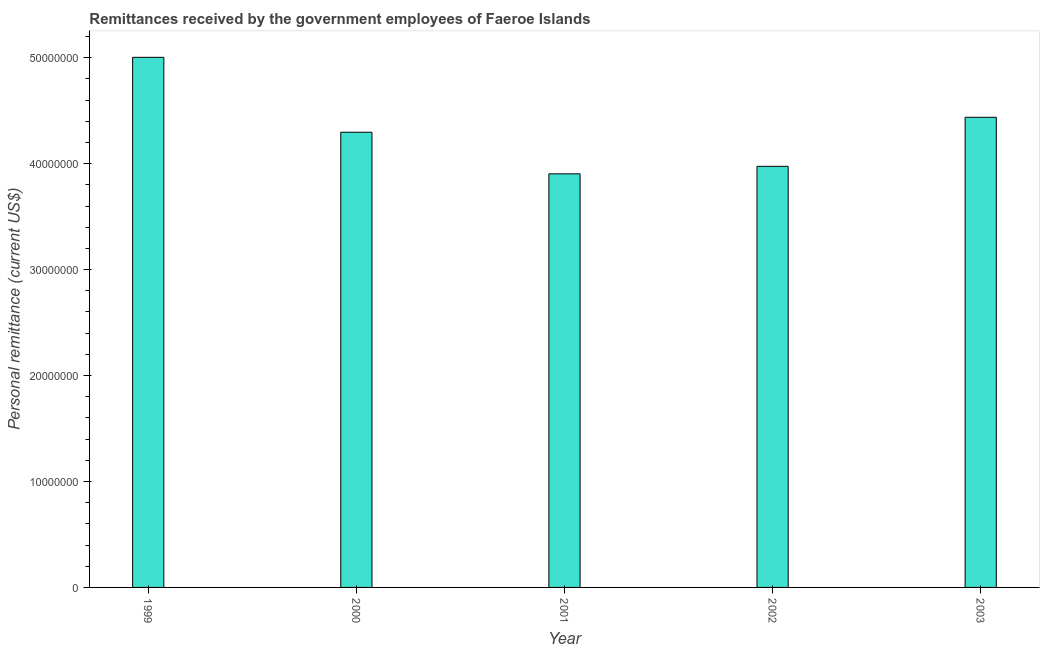Does the graph contain any zero values?
Your answer should be compact. No. Does the graph contain grids?
Provide a succinct answer. No. What is the title of the graph?
Give a very brief answer. Remittances received by the government employees of Faeroe Islands. What is the label or title of the X-axis?
Keep it short and to the point. Year. What is the label or title of the Y-axis?
Give a very brief answer. Personal remittance (current US$). What is the personal remittances in 2003?
Provide a succinct answer. 4.44e+07. Across all years, what is the maximum personal remittances?
Offer a very short reply. 5.00e+07. Across all years, what is the minimum personal remittances?
Your answer should be very brief. 3.90e+07. What is the sum of the personal remittances?
Offer a terse response. 2.16e+08. What is the difference between the personal remittances in 2000 and 2002?
Provide a short and direct response. 3.22e+06. What is the average personal remittances per year?
Give a very brief answer. 4.32e+07. What is the median personal remittances?
Offer a very short reply. 4.30e+07. In how many years, is the personal remittances greater than 30000000 US$?
Make the answer very short. 5. Do a majority of the years between 2002 and 2000 (inclusive) have personal remittances greater than 48000000 US$?
Keep it short and to the point. Yes. What is the ratio of the personal remittances in 2001 to that in 2002?
Ensure brevity in your answer.  0.98. Is the personal remittances in 2001 less than that in 2002?
Offer a terse response. Yes. What is the difference between the highest and the second highest personal remittances?
Offer a terse response. 5.66e+06. Is the sum of the personal remittances in 1999 and 2000 greater than the maximum personal remittances across all years?
Your answer should be very brief. Yes. What is the difference between the highest and the lowest personal remittances?
Provide a succinct answer. 1.10e+07. In how many years, is the personal remittances greater than the average personal remittances taken over all years?
Ensure brevity in your answer.  2. Are all the bars in the graph horizontal?
Provide a succinct answer. No. What is the difference between two consecutive major ticks on the Y-axis?
Your answer should be compact. 1.00e+07. What is the Personal remittance (current US$) in 1999?
Your answer should be very brief. 5.00e+07. What is the Personal remittance (current US$) of 2000?
Your answer should be compact. 4.30e+07. What is the Personal remittance (current US$) of 2001?
Offer a terse response. 3.90e+07. What is the Personal remittance (current US$) in 2002?
Offer a terse response. 3.98e+07. What is the Personal remittance (current US$) in 2003?
Keep it short and to the point. 4.44e+07. What is the difference between the Personal remittance (current US$) in 1999 and 2000?
Offer a terse response. 7.07e+06. What is the difference between the Personal remittance (current US$) in 1999 and 2001?
Your answer should be compact. 1.10e+07. What is the difference between the Personal remittance (current US$) in 1999 and 2002?
Your answer should be compact. 1.03e+07. What is the difference between the Personal remittance (current US$) in 1999 and 2003?
Make the answer very short. 5.66e+06. What is the difference between the Personal remittance (current US$) in 2000 and 2001?
Your answer should be compact. 3.93e+06. What is the difference between the Personal remittance (current US$) in 2000 and 2002?
Your response must be concise. 3.22e+06. What is the difference between the Personal remittance (current US$) in 2000 and 2003?
Offer a very short reply. -1.41e+06. What is the difference between the Personal remittance (current US$) in 2001 and 2002?
Offer a very short reply. -7.10e+05. What is the difference between the Personal remittance (current US$) in 2001 and 2003?
Your answer should be very brief. -5.34e+06. What is the difference between the Personal remittance (current US$) in 2002 and 2003?
Your response must be concise. -4.63e+06. What is the ratio of the Personal remittance (current US$) in 1999 to that in 2000?
Your answer should be compact. 1.17. What is the ratio of the Personal remittance (current US$) in 1999 to that in 2001?
Offer a terse response. 1.28. What is the ratio of the Personal remittance (current US$) in 1999 to that in 2002?
Offer a very short reply. 1.26. What is the ratio of the Personal remittance (current US$) in 1999 to that in 2003?
Your answer should be very brief. 1.13. What is the ratio of the Personal remittance (current US$) in 2000 to that in 2001?
Give a very brief answer. 1.1. What is the ratio of the Personal remittance (current US$) in 2000 to that in 2002?
Make the answer very short. 1.08. What is the ratio of the Personal remittance (current US$) in 2000 to that in 2003?
Give a very brief answer. 0.97. What is the ratio of the Personal remittance (current US$) in 2002 to that in 2003?
Offer a terse response. 0.9. 